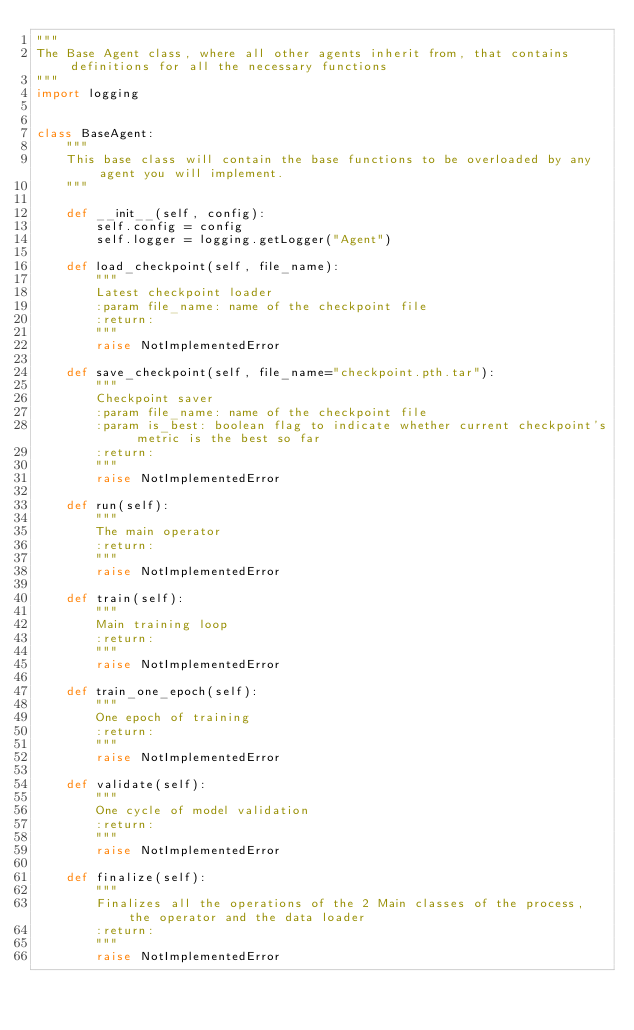<code> <loc_0><loc_0><loc_500><loc_500><_Python_>"""
The Base Agent class, where all other agents inherit from, that contains definitions for all the necessary functions
"""
import logging


class BaseAgent:
    """
    This base class will contain the base functions to be overloaded by any agent you will implement.
    """

    def __init__(self, config):
        self.config = config
        self.logger = logging.getLogger("Agent")

    def load_checkpoint(self, file_name):
        """
        Latest checkpoint loader
        :param file_name: name of the checkpoint file
        :return:
        """
        raise NotImplementedError

    def save_checkpoint(self, file_name="checkpoint.pth.tar"):
        """
        Checkpoint saver
        :param file_name: name of the checkpoint file
        :param is_best: boolean flag to indicate whether current checkpoint's metric is the best so far
        :return:
        """
        raise NotImplementedError

    def run(self):
        """
        The main operator
        :return:
        """
        raise NotImplementedError

    def train(self):
        """
        Main training loop
        :return:
        """
        raise NotImplementedError

    def train_one_epoch(self):
        """
        One epoch of training
        :return:
        """
        raise NotImplementedError

    def validate(self):
        """
        One cycle of model validation
        :return:
        """
        raise NotImplementedError

    def finalize(self):
        """
        Finalizes all the operations of the 2 Main classes of the process, the operator and the data loader
        :return:
        """
        raise NotImplementedError
</code> 